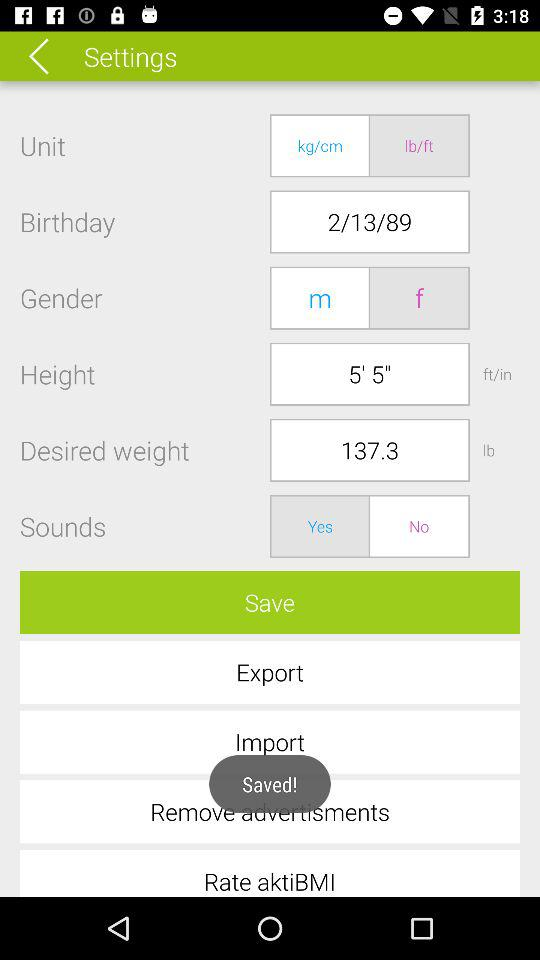What is the selected unit? The selected unit is "lb/ft". 